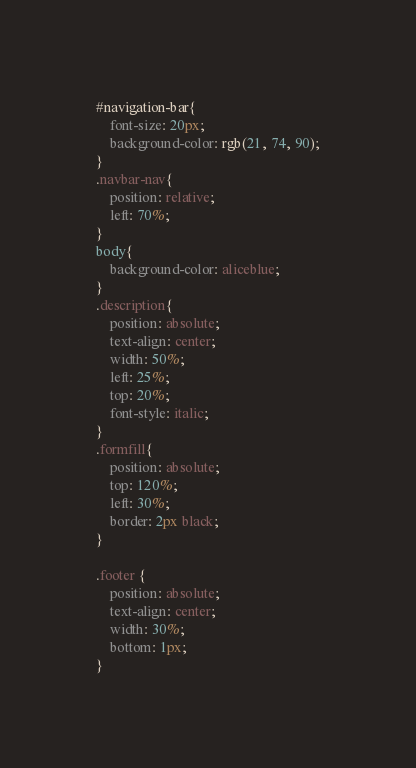<code> <loc_0><loc_0><loc_500><loc_500><_CSS_>#navigation-bar{
    font-size: 20px;
    background-color: rgb(21, 74, 90);
}
.navbar-nav{
    position: relative;
    left: 70%;
}
body{
    background-color: aliceblue;
}
.description{
    position: absolute;
    text-align: center;
    width: 50%;
    left: 25%;
    top: 20%;
    font-style: italic;
} 
.formfill{
    position: absolute;
    top: 120%;
    left: 30%;
    border: 2px black;
}

.footer {
    position: absolute;
    text-align: center;
    width: 30%;
    bottom: 1px;
}


</code> 